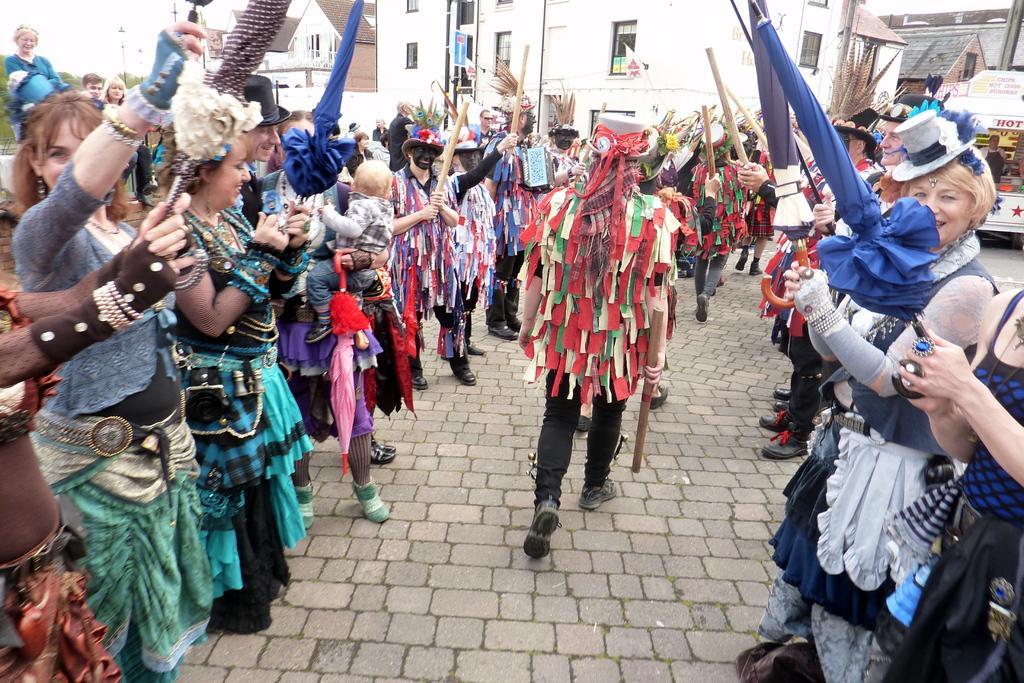In one or two sentences, can you explain what this image depicts? In this image we can see many persons with costumes on the road. In the background we can see buildings, trees and sky. 